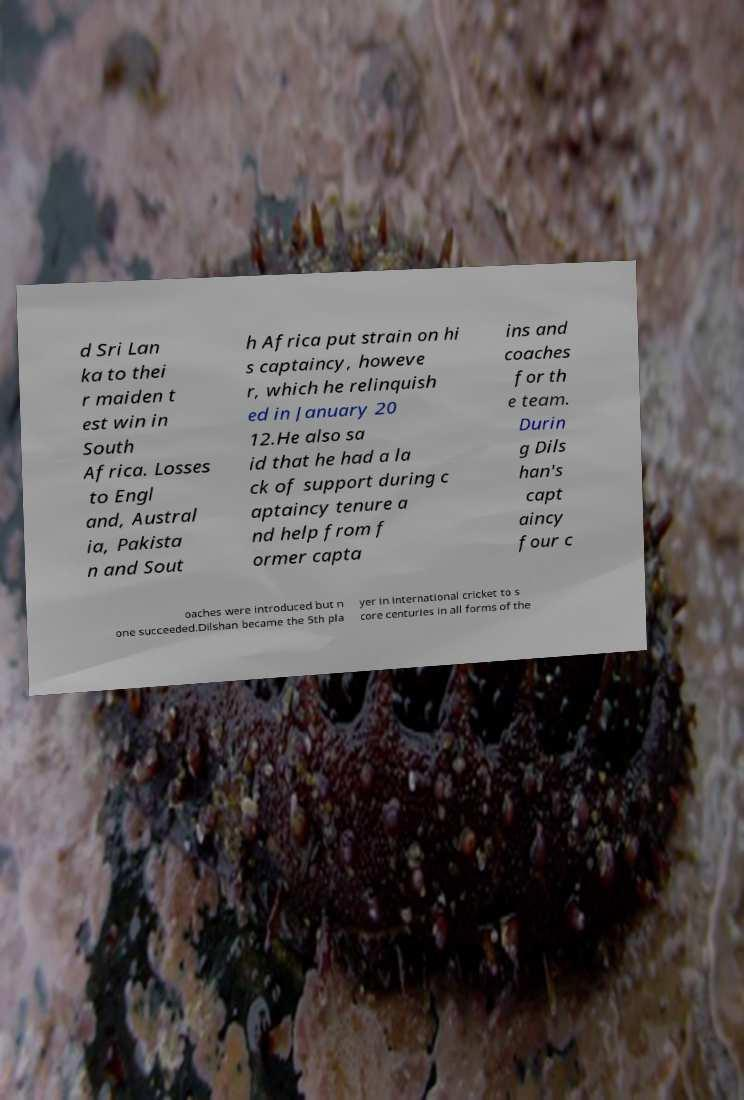Can you accurately transcribe the text from the provided image for me? d Sri Lan ka to thei r maiden t est win in South Africa. Losses to Engl and, Austral ia, Pakista n and Sout h Africa put strain on hi s captaincy, howeve r, which he relinquish ed in January 20 12.He also sa id that he had a la ck of support during c aptaincy tenure a nd help from f ormer capta ins and coaches for th e team. Durin g Dils han's capt aincy four c oaches were introduced but n one succeeded.Dilshan became the 5th pla yer in international cricket to s core centuries in all forms of the 